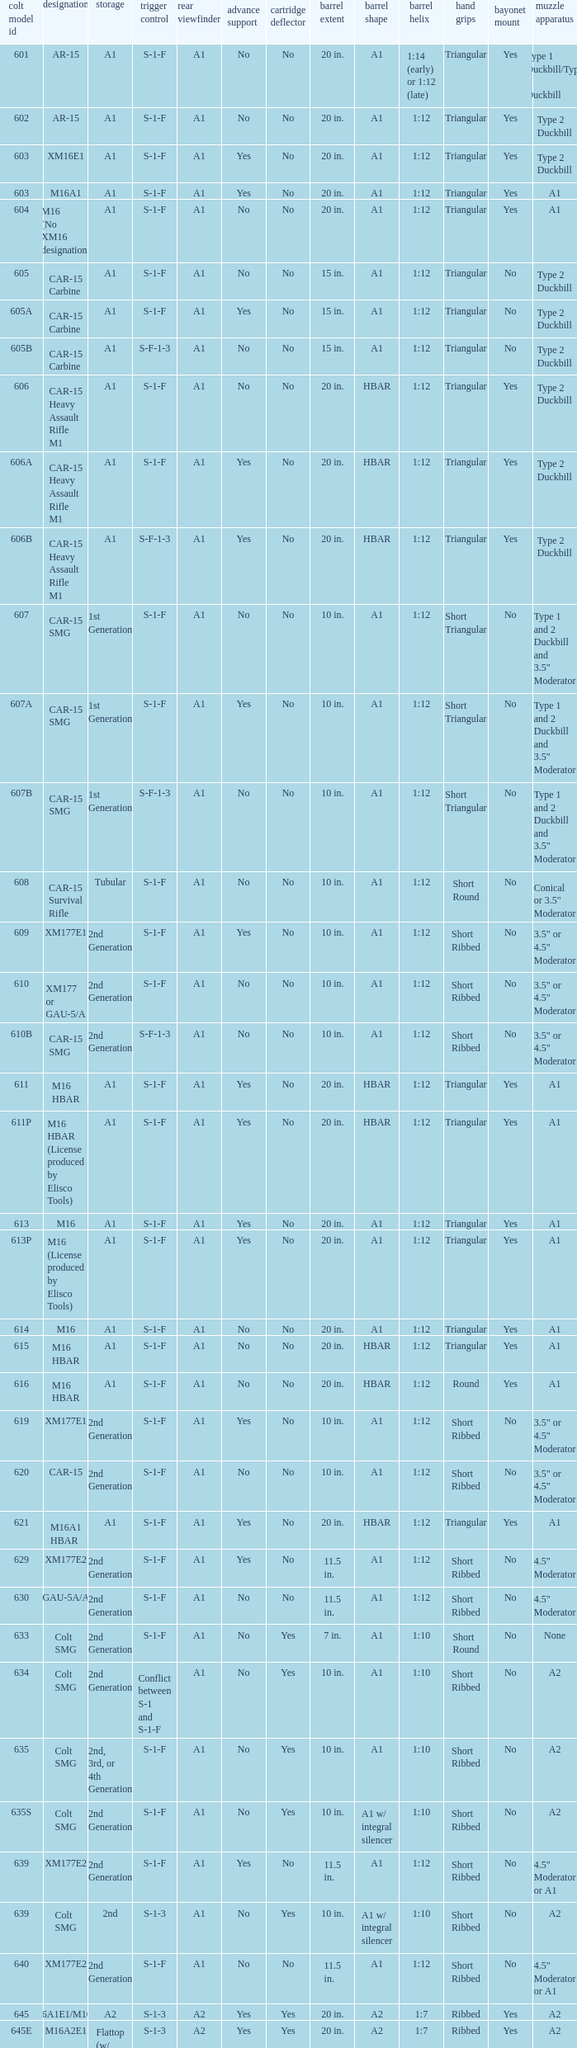What's the type of muzzle devices on the models with round hand guards? A1. 